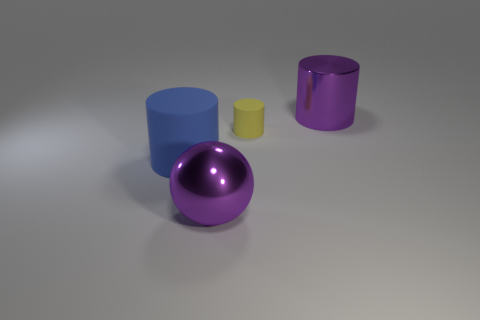Add 2 purple objects. How many objects exist? 6 Subtract 1 balls. How many balls are left? 0 Subtract all rubber cylinders. How many cylinders are left? 1 Subtract all purple cylinders. How many cylinders are left? 2 Subtract 0 cyan balls. How many objects are left? 4 Subtract all cylinders. How many objects are left? 1 Subtract all green cylinders. Subtract all green blocks. How many cylinders are left? 3 Subtract all green cylinders. How many red spheres are left? 0 Subtract all purple shiny cylinders. Subtract all big rubber cylinders. How many objects are left? 2 Add 2 small yellow rubber cylinders. How many small yellow rubber cylinders are left? 3 